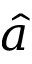<formula> <loc_0><loc_0><loc_500><loc_500>\hat { a }</formula> 